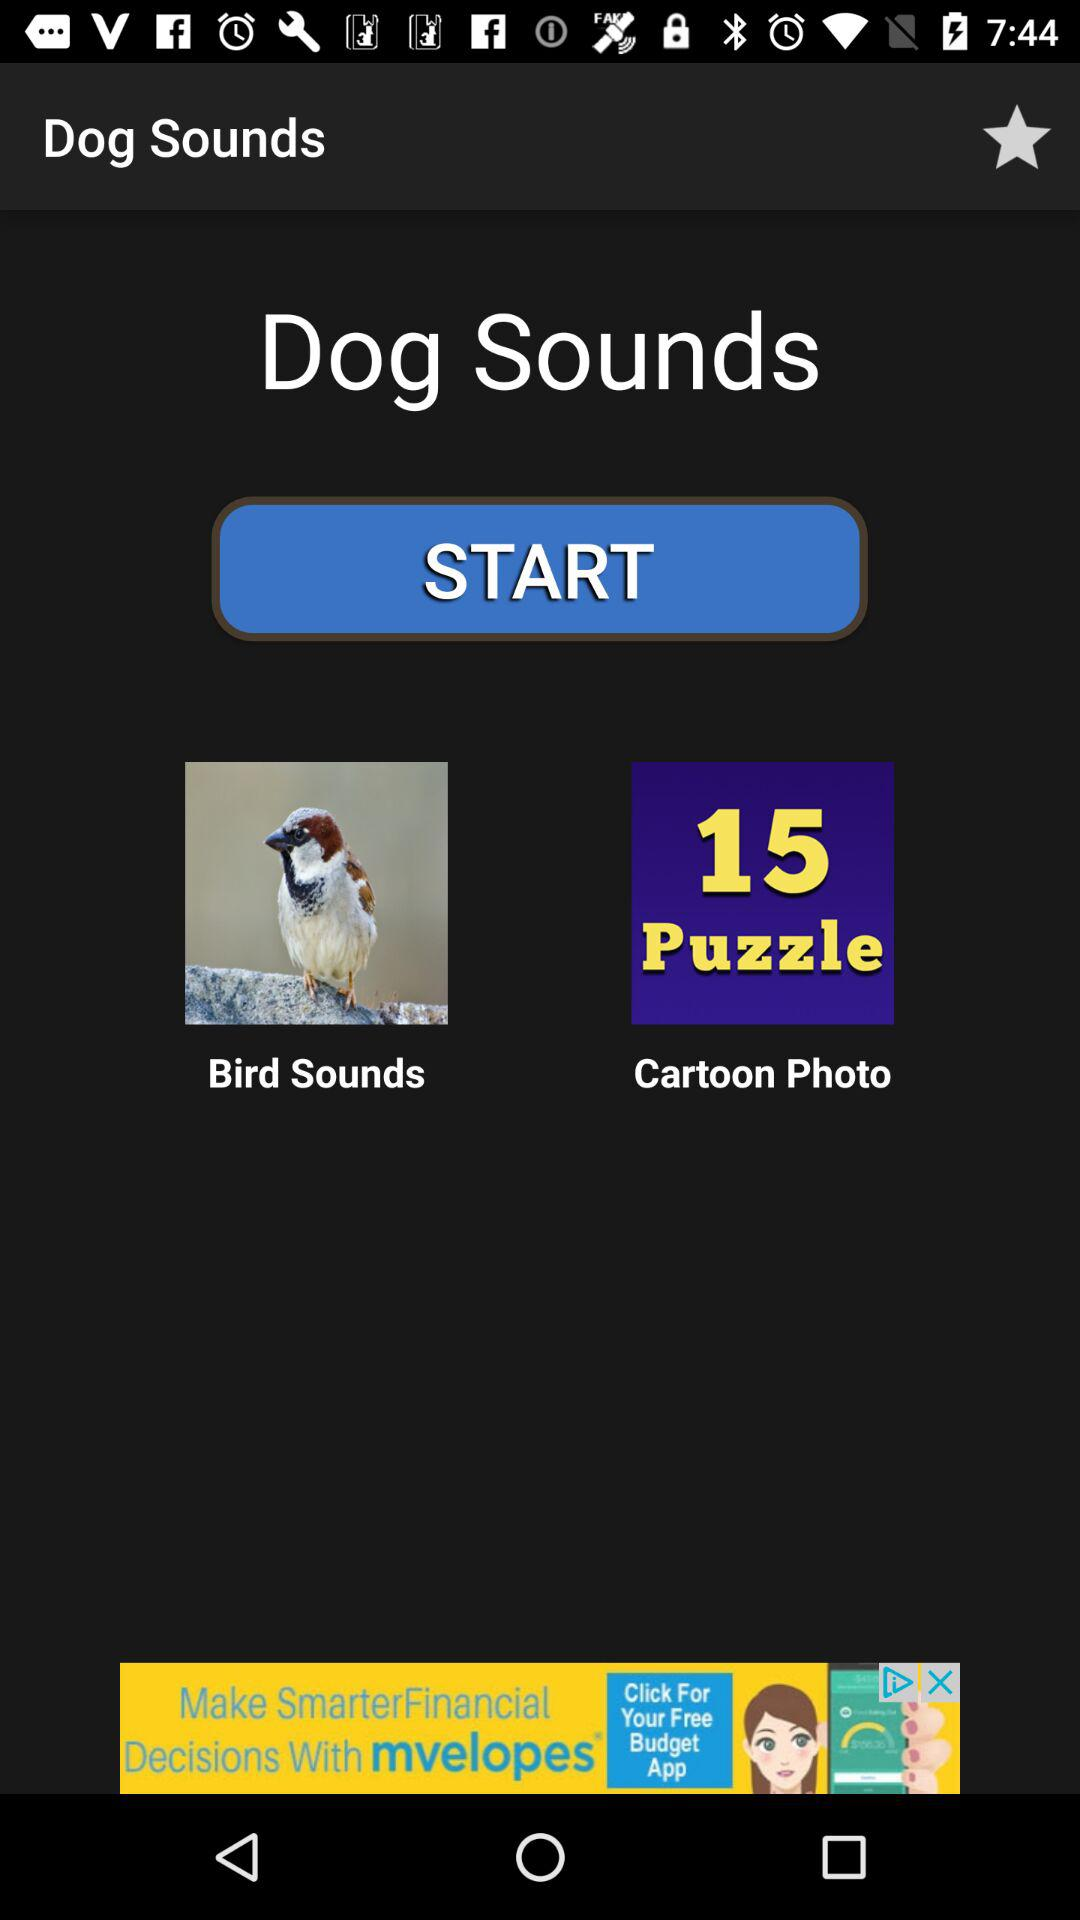What is the number of puzzles? There are 15 puzzles. 